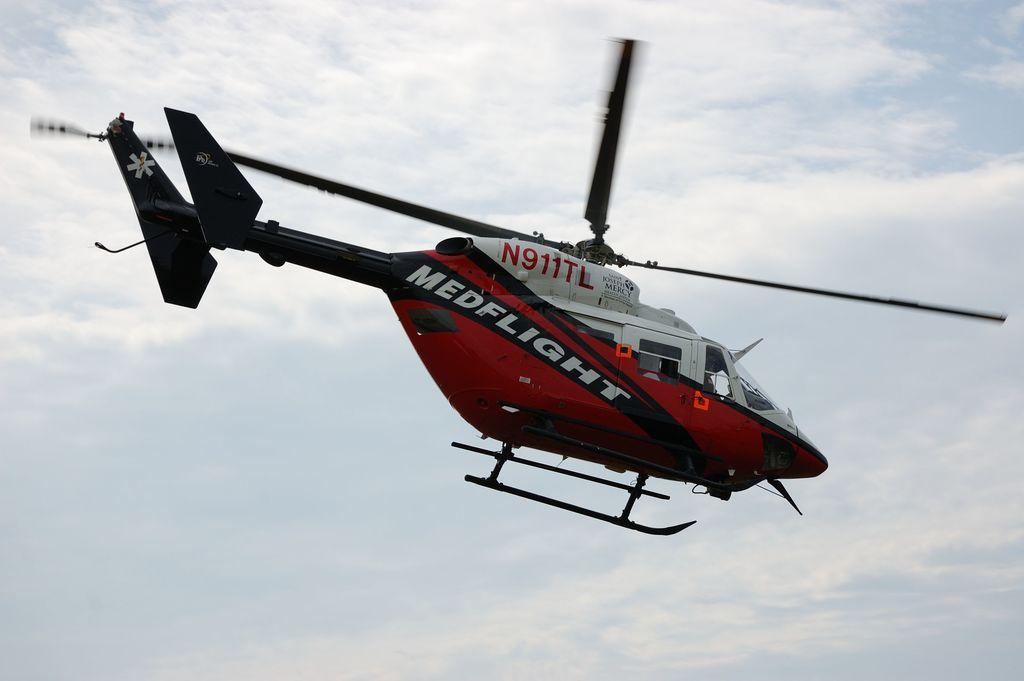<image>
Give a short and clear explanation of the subsequent image. a red and white helicopter that says medflight on it 